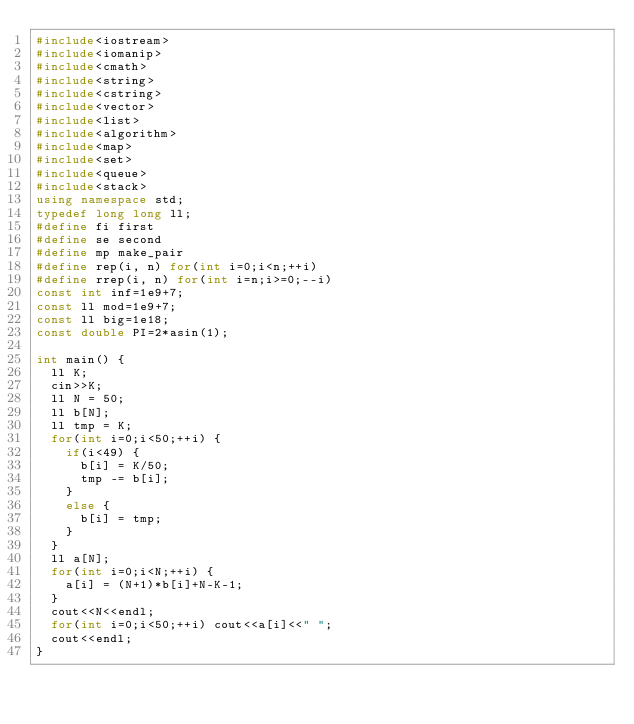<code> <loc_0><loc_0><loc_500><loc_500><_C++_>#include<iostream>
#include<iomanip>
#include<cmath>
#include<string>
#include<cstring>
#include<vector>
#include<list>
#include<algorithm>
#include<map>
#include<set>
#include<queue>
#include<stack>
using namespace std;
typedef long long ll;
#define fi first
#define se second
#define mp make_pair
#define rep(i, n) for(int i=0;i<n;++i)
#define rrep(i, n) for(int i=n;i>=0;--i)
const int inf=1e9+7;
const ll mod=1e9+7;
const ll big=1e18;
const double PI=2*asin(1);

int main() {
  ll K;
  cin>>K;
  ll N = 50;
  ll b[N];
  ll tmp = K;
  for(int i=0;i<50;++i) {
    if(i<49) {
      b[i] = K/50;
      tmp -= b[i];
    }
    else {
      b[i] = tmp;
    }
  }
  ll a[N];
  for(int i=0;i<N;++i) {
    a[i] = (N+1)*b[i]+N-K-1;
  }
  cout<<N<<endl;
  for(int i=0;i<50;++i) cout<<a[i]<<" ";
  cout<<endl;
}

</code> 